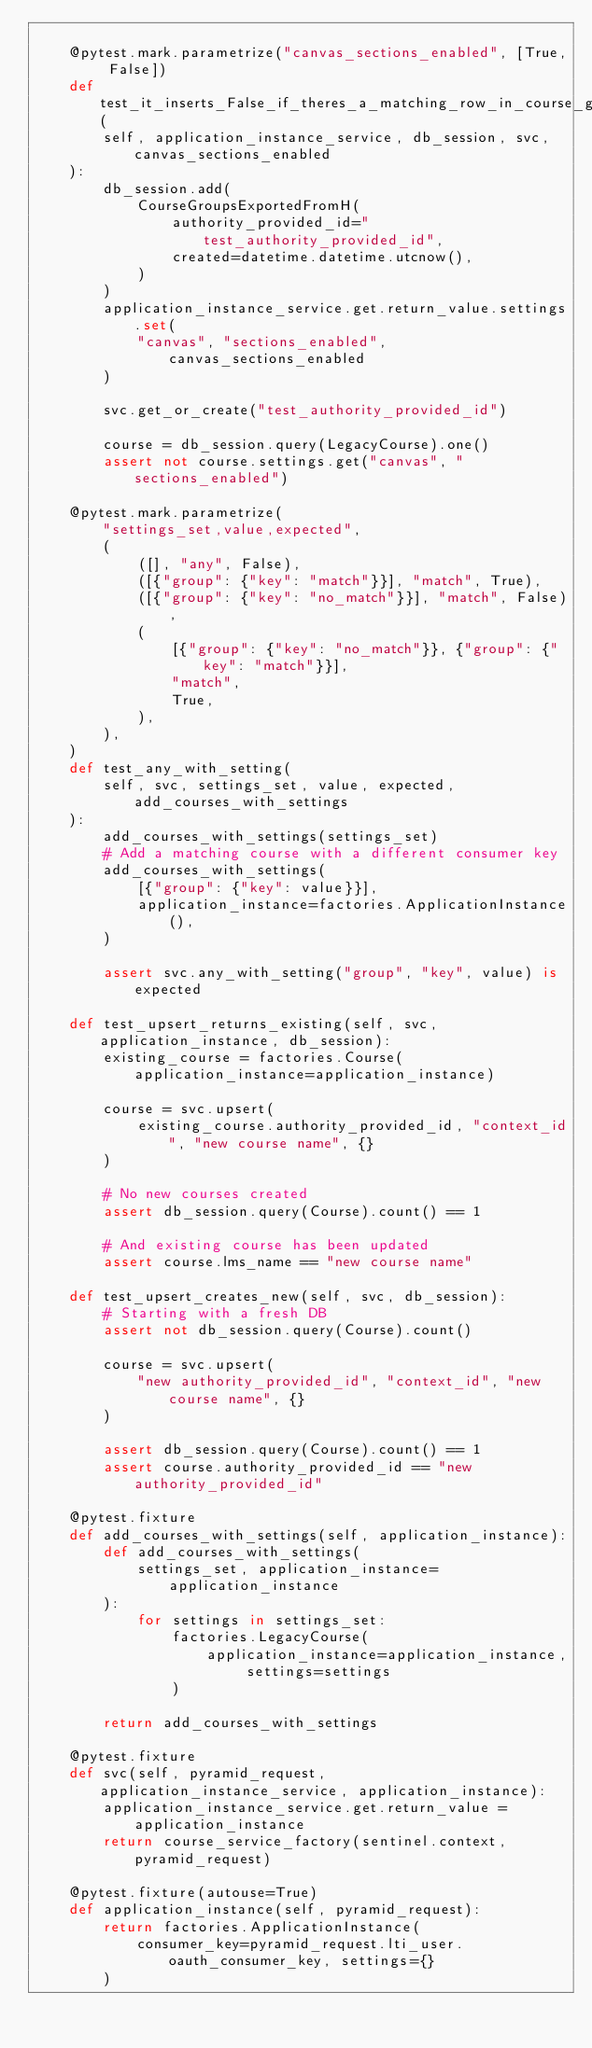Convert code to text. <code><loc_0><loc_0><loc_500><loc_500><_Python_>
    @pytest.mark.parametrize("canvas_sections_enabled", [True, False])
    def test_it_inserts_False_if_theres_a_matching_row_in_course_groups_exported_from_h(
        self, application_instance_service, db_session, svc, canvas_sections_enabled
    ):
        db_session.add(
            CourseGroupsExportedFromH(
                authority_provided_id="test_authority_provided_id",
                created=datetime.datetime.utcnow(),
            )
        )
        application_instance_service.get.return_value.settings.set(
            "canvas", "sections_enabled", canvas_sections_enabled
        )

        svc.get_or_create("test_authority_provided_id")

        course = db_session.query(LegacyCourse).one()
        assert not course.settings.get("canvas", "sections_enabled")

    @pytest.mark.parametrize(
        "settings_set,value,expected",
        (
            ([], "any", False),
            ([{"group": {"key": "match"}}], "match", True),
            ([{"group": {"key": "no_match"}}], "match", False),
            (
                [{"group": {"key": "no_match"}}, {"group": {"key": "match"}}],
                "match",
                True,
            ),
        ),
    )
    def test_any_with_setting(
        self, svc, settings_set, value, expected, add_courses_with_settings
    ):
        add_courses_with_settings(settings_set)
        # Add a matching course with a different consumer key
        add_courses_with_settings(
            [{"group": {"key": value}}],
            application_instance=factories.ApplicationInstance(),
        )

        assert svc.any_with_setting("group", "key", value) is expected

    def test_upsert_returns_existing(self, svc, application_instance, db_session):
        existing_course = factories.Course(application_instance=application_instance)

        course = svc.upsert(
            existing_course.authority_provided_id, "context_id", "new course name", {}
        )

        # No new courses created
        assert db_session.query(Course).count() == 1

        # And existing course has been updated
        assert course.lms_name == "new course name"

    def test_upsert_creates_new(self, svc, db_session):
        # Starting with a fresh DB
        assert not db_session.query(Course).count()

        course = svc.upsert(
            "new authority_provided_id", "context_id", "new course name", {}
        )

        assert db_session.query(Course).count() == 1
        assert course.authority_provided_id == "new authority_provided_id"

    @pytest.fixture
    def add_courses_with_settings(self, application_instance):
        def add_courses_with_settings(
            settings_set, application_instance=application_instance
        ):
            for settings in settings_set:
                factories.LegacyCourse(
                    application_instance=application_instance, settings=settings
                )

        return add_courses_with_settings

    @pytest.fixture
    def svc(self, pyramid_request, application_instance_service, application_instance):
        application_instance_service.get.return_value = application_instance
        return course_service_factory(sentinel.context, pyramid_request)

    @pytest.fixture(autouse=True)
    def application_instance(self, pyramid_request):
        return factories.ApplicationInstance(
            consumer_key=pyramid_request.lti_user.oauth_consumer_key, settings={}
        )
</code> 